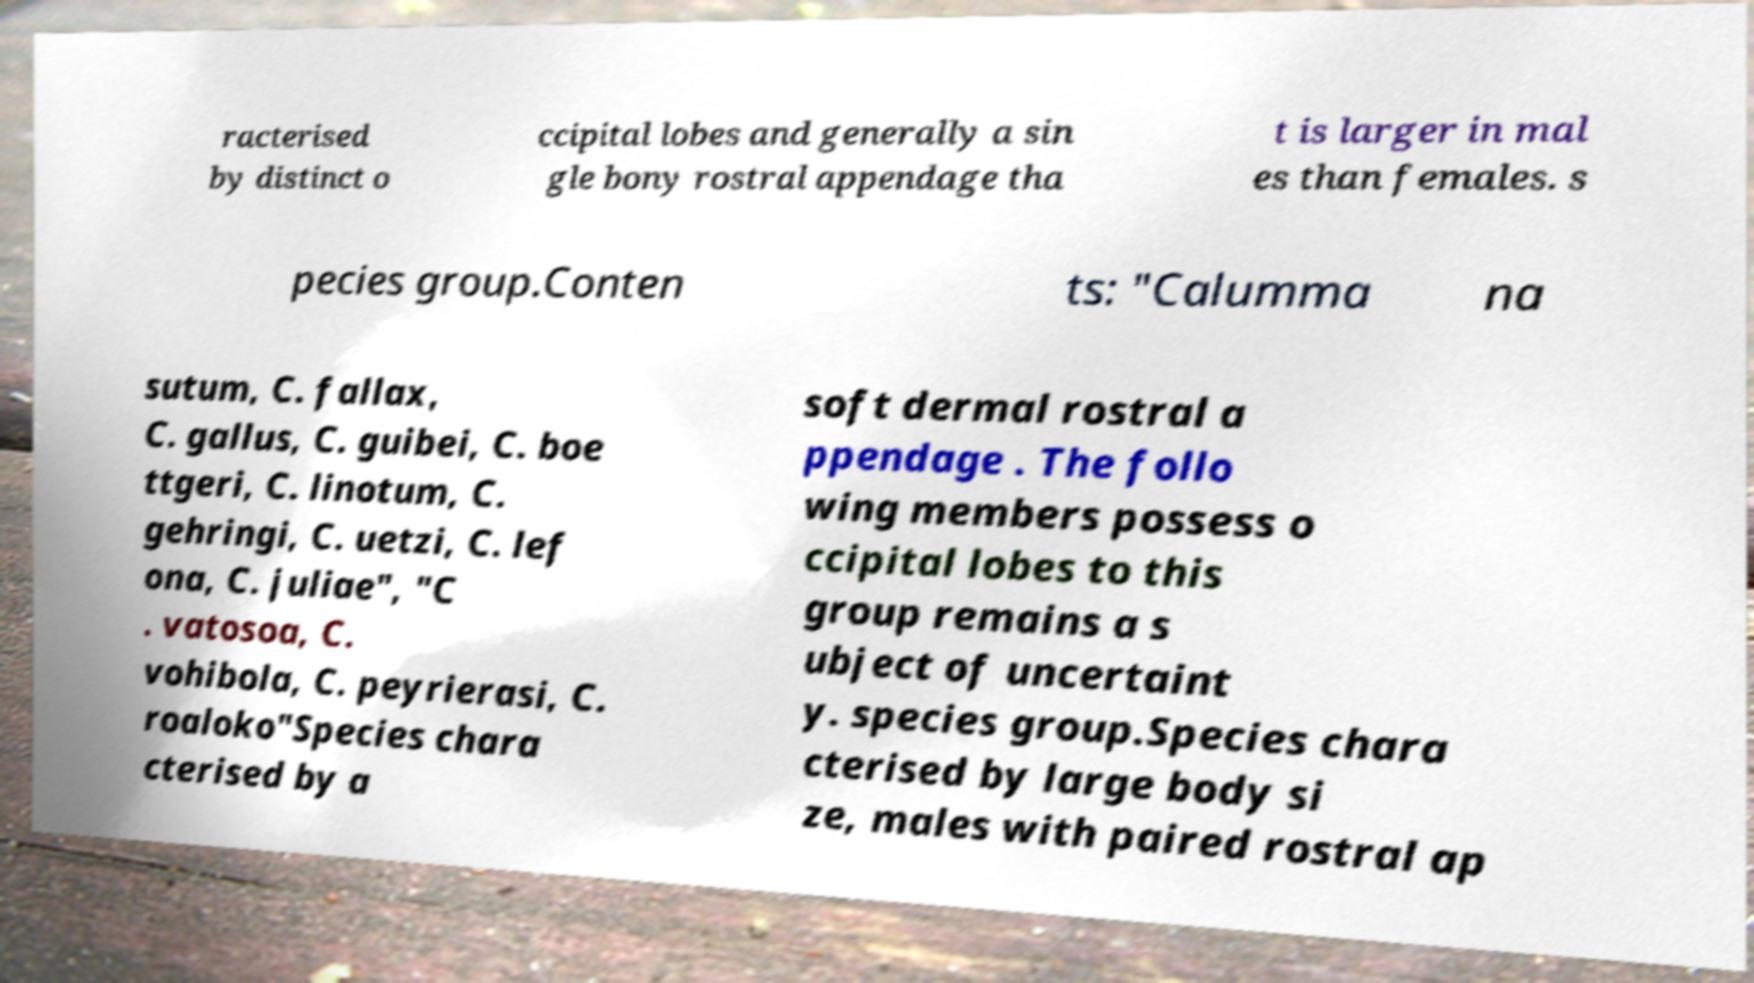Can you read and provide the text displayed in the image?This photo seems to have some interesting text. Can you extract and type it out for me? racterised by distinct o ccipital lobes and generally a sin gle bony rostral appendage tha t is larger in mal es than females. s pecies group.Conten ts: "Calumma na sutum, C. fallax, C. gallus, C. guibei, C. boe ttgeri, C. linotum, C. gehringi, C. uetzi, C. lef ona, C. juliae", "C . vatosoa, C. vohibola, C. peyrierasi, C. roaloko"Species chara cterised by a soft dermal rostral a ppendage . The follo wing members possess o ccipital lobes to this group remains a s ubject of uncertaint y. species group.Species chara cterised by large body si ze, males with paired rostral ap 